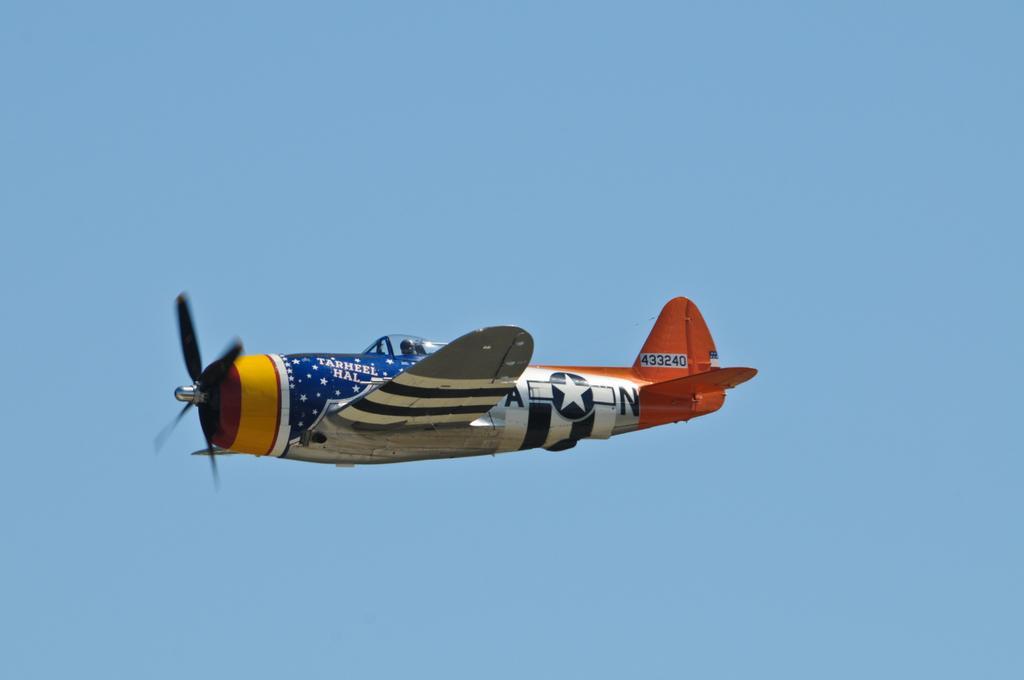In one or two sentences, can you explain what this image depicts? In this picture I can see a jet plane and a blue sky in the background. 